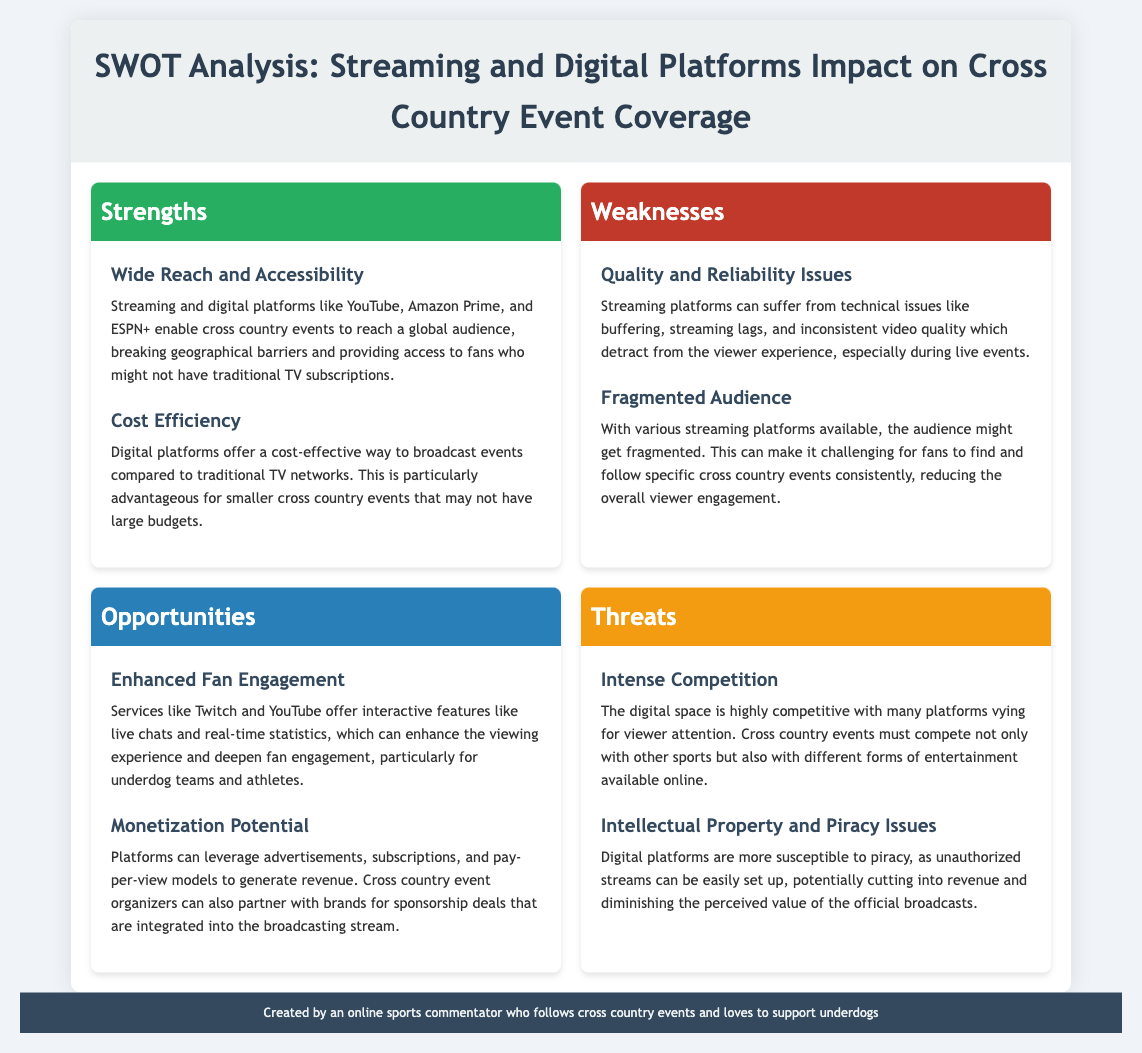what is one strength of streaming platforms for cross country events? One strength highlighted is “Wide Reach and Accessibility,” which allows events to reach a global audience.
Answer: Wide Reach and Accessibility what is a weakness associated with streaming platforms? The document states that “Quality and Reliability Issues” are a weakness, as streaming can suffer from technical issues.
Answer: Quality and Reliability Issues what opportunity is mentioned in enhancing fan engagement? The document discusses “Enhanced Fan Engagement” through interactive features on platforms like Twitch and YouTube.
Answer: Enhanced Fan Engagement how can digital platforms potentially generate revenue? The document states that platforms can leverage “advertisements, subscriptions, and pay-per-view models” for monetization.
Answer: advertisements, subscriptions, and pay-per-view models what threat do cross country events face regarding competition? Intense competition is mentioned as a threat in the document, indicating a highly competitive digital space.
Answer: Intense Competition what is a specific problem associated with unauthorized streaming? The document notes that “Intellectual Property and Piracy Issues” are a concern, as piracy can diminish the value of official broadcasts.
Answer: Intellectual Property and Piracy Issues which platforms are mentioned that could enhance fan engagement? The document mentions “Twitch and YouTube” as services that offer interactive features during events.
Answer: Twitch and YouTube what does cost efficiency refer to in the context of digital platforms? “Cost Efficiency” pertains to the lower costs of broadcasting events on digital platforms compared to traditional TV networks.
Answer: Cost Efficiency what does fragmented audience imply for cross country events? The document indicates that a fragmented audience can make it challenging for fans to find and follow events consistently.
Answer: fragmented audience 